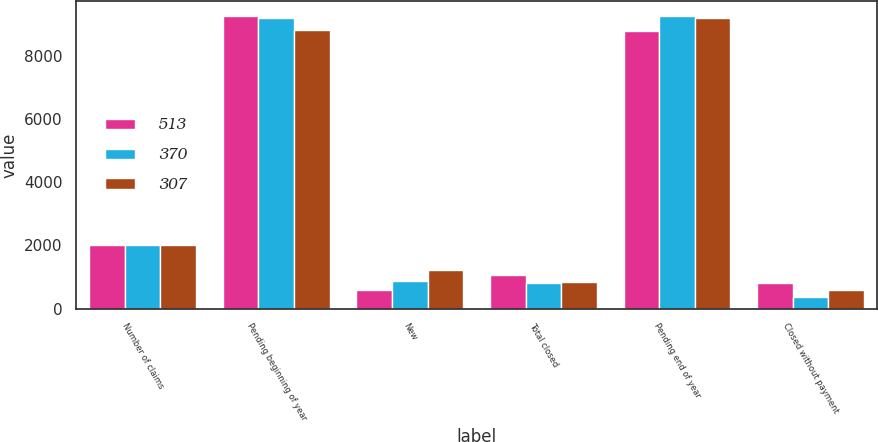Convert chart. <chart><loc_0><loc_0><loc_500><loc_500><stacked_bar_chart><ecel><fcel>Number of claims<fcel>Pending beginning of year<fcel>New<fcel>Total closed<fcel>Pending end of year<fcel>Closed without payment<nl><fcel>513<fcel>2008<fcel>9256<fcel>601<fcel>1077<fcel>8780<fcel>800<nl><fcel>370<fcel>2007<fcel>9175<fcel>876<fcel>795<fcel>9256<fcel>364<nl><fcel>307<fcel>2006<fcel>8806<fcel>1220<fcel>851<fcel>9175<fcel>596<nl></chart> 